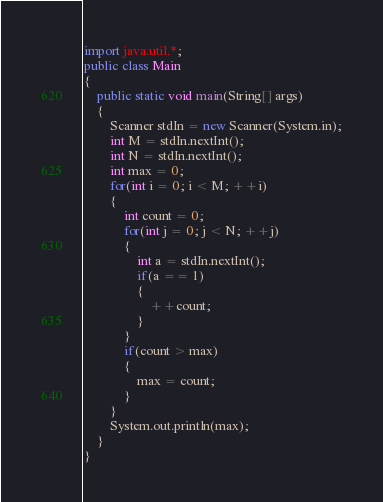<code> <loc_0><loc_0><loc_500><loc_500><_Java_>import java.util.*;
public class Main 
{
	public static void main(String[] args) 
	{
		Scanner stdIn = new Scanner(System.in);
		int M = stdIn.nextInt();
		int N = stdIn.nextInt();
		int max = 0;
		for(int i = 0; i < M; ++i)
		{
			int count = 0;
			for(int j = 0; j < N; ++j)
			{
				int a = stdIn.nextInt();
				if(a == 1)
				{
					++count;
				}
			}
			if(count > max)
			{
				max = count;
			}
		}
		System.out.println(max);
	}
}</code> 